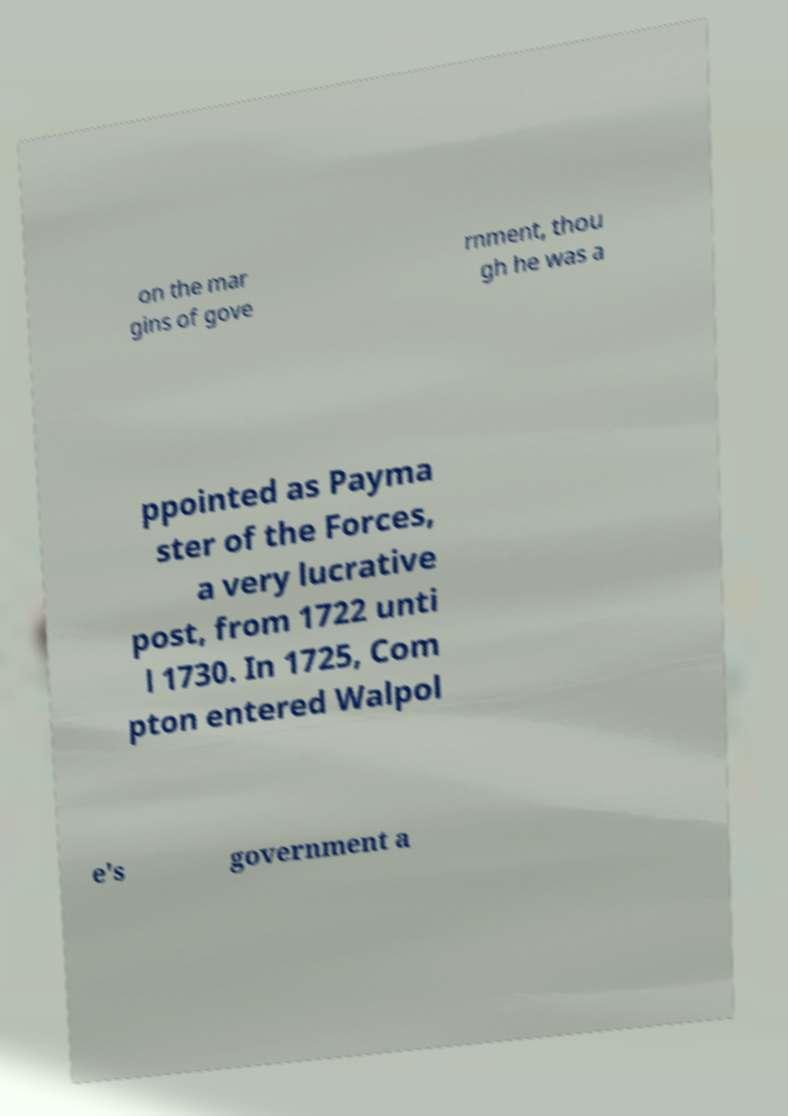Can you read and provide the text displayed in the image?This photo seems to have some interesting text. Can you extract and type it out for me? on the mar gins of gove rnment, thou gh he was a ppointed as Payma ster of the Forces, a very lucrative post, from 1722 unti l 1730. In 1725, Com pton entered Walpol e's government a 